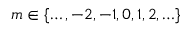<formula> <loc_0><loc_0><loc_500><loc_500>m \in \{ \dots , - 2 , - 1 , 0 , 1 , 2 , \dots \}</formula> 